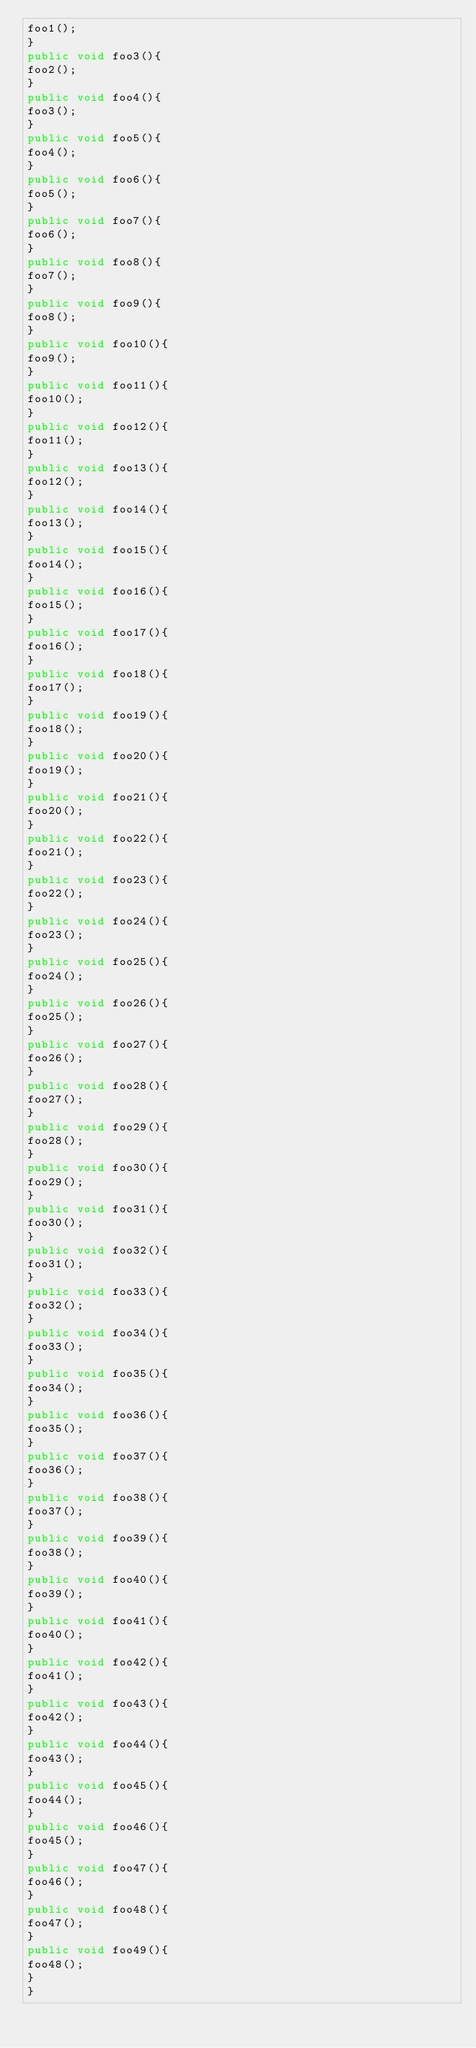Convert code to text. <code><loc_0><loc_0><loc_500><loc_500><_Java_>foo1();
}
public void foo3(){
foo2();
}
public void foo4(){
foo3();
}
public void foo5(){
foo4();
}
public void foo6(){
foo5();
}
public void foo7(){
foo6();
}
public void foo8(){
foo7();
}
public void foo9(){
foo8();
}
public void foo10(){
foo9();
}
public void foo11(){
foo10();
}
public void foo12(){
foo11();
}
public void foo13(){
foo12();
}
public void foo14(){
foo13();
}
public void foo15(){
foo14();
}
public void foo16(){
foo15();
}
public void foo17(){
foo16();
}
public void foo18(){
foo17();
}
public void foo19(){
foo18();
}
public void foo20(){
foo19();
}
public void foo21(){
foo20();
}
public void foo22(){
foo21();
}
public void foo23(){
foo22();
}
public void foo24(){
foo23();
}
public void foo25(){
foo24();
}
public void foo26(){
foo25();
}
public void foo27(){
foo26();
}
public void foo28(){
foo27();
}
public void foo29(){
foo28();
}
public void foo30(){
foo29();
}
public void foo31(){
foo30();
}
public void foo32(){
foo31();
}
public void foo33(){
foo32();
}
public void foo34(){
foo33();
}
public void foo35(){
foo34();
}
public void foo36(){
foo35();
}
public void foo37(){
foo36();
}
public void foo38(){
foo37();
}
public void foo39(){
foo38();
}
public void foo40(){
foo39();
}
public void foo41(){
foo40();
}
public void foo42(){
foo41();
}
public void foo43(){
foo42();
}
public void foo44(){
foo43();
}
public void foo45(){
foo44();
}
public void foo46(){
foo45();
}
public void foo47(){
foo46();
}
public void foo48(){
foo47();
}
public void foo49(){
foo48();
}
}</code> 